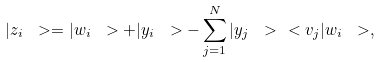Convert formula to latex. <formula><loc_0><loc_0><loc_500><loc_500>| z _ { i } \ > = | w _ { i } \ > + | y _ { i } \ > - \sum _ { j = 1 } ^ { N } | y _ { j } \ > \ < v _ { j } | w _ { i } \ > ,</formula> 